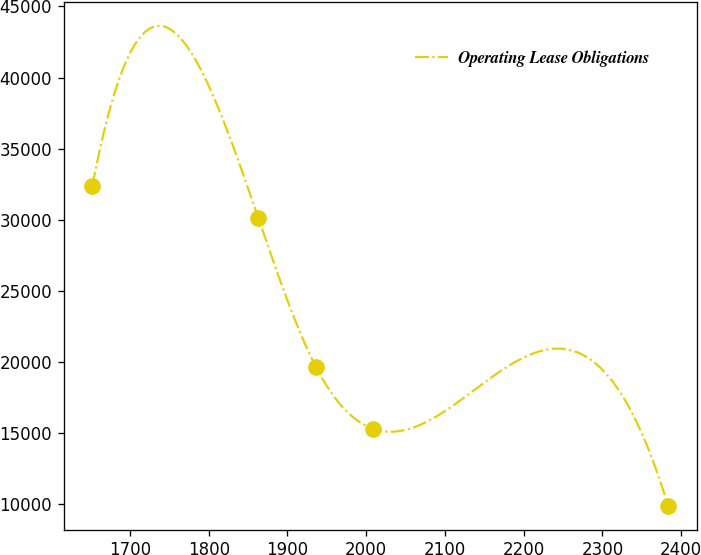Convert chart. <chart><loc_0><loc_0><loc_500><loc_500><line_chart><ecel><fcel>Operating Lease Obligations<nl><fcel>1652.28<fcel>32410.3<nl><fcel>1862.89<fcel>30138.8<nl><fcel>1935.99<fcel>19674.5<nl><fcel>2009.09<fcel>15307.7<nl><fcel>2383.28<fcel>9912.08<nl></chart> 